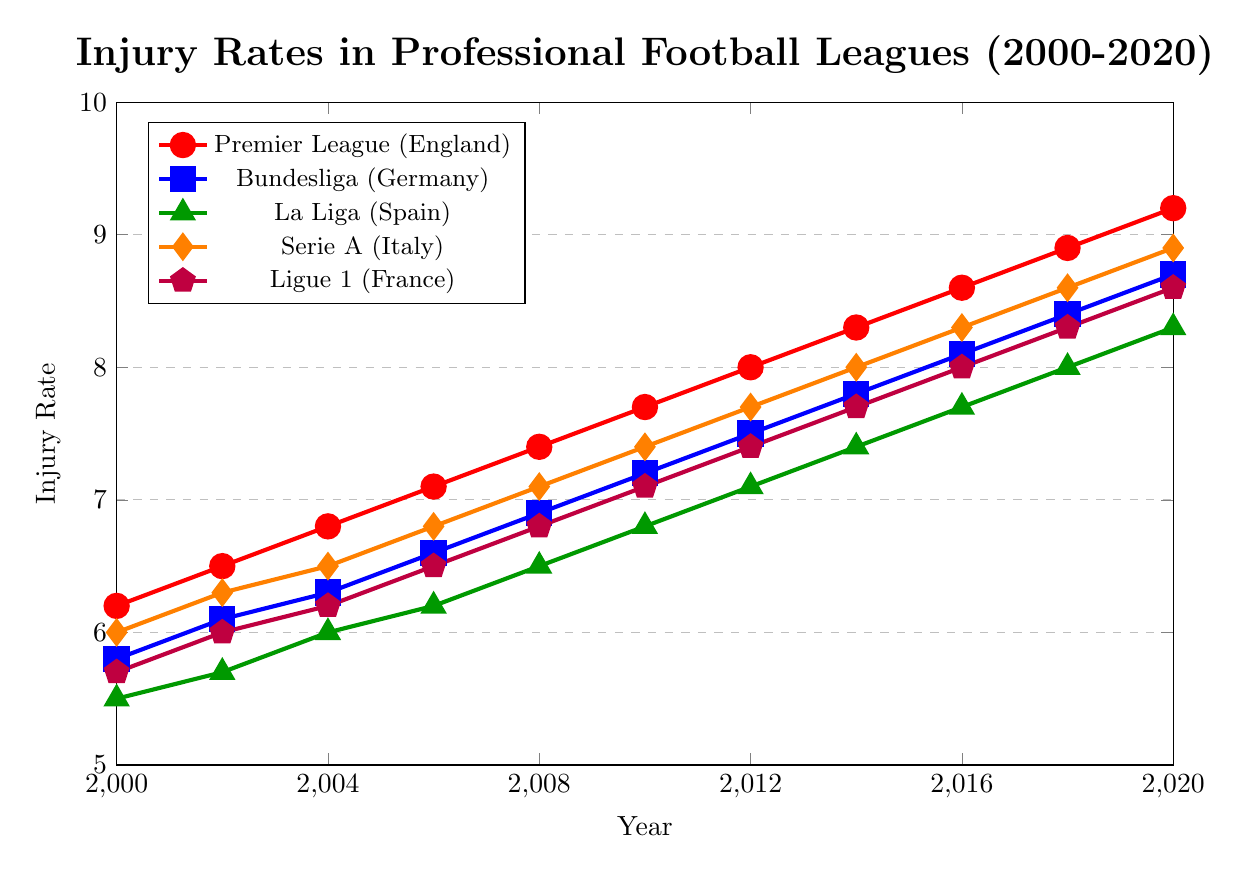What's the trend of injury rates in the Premier League (England) from 2000 to 2020? The red line representing the Premier League (England) shows a consistent upward trend from 2000 (6.2) to 2020 (9.2). Each point along the red line marks an increase over time, indicating a steady rise in injury rates for this league over the 20-year period.
Answer: Upward trend Which league had the lowest injury rate in 2000 and what was the rate? In 2000, the green line representing La Liga (Spain) is the lowest among all the lines, with an injury rate of 5.5.
Answer: La Liga (Spain), 5.5 By how much did the injury rate increase in Serie A (Italy) from 2000 to 2020? The orange line representing Serie A (Italy) starts at 6.0 in 2000 and ends at 8.9 in 2020. The increase can be calculated as 8.9 - 6.0 = 2.9.
Answer: 2.9 Which league's injury rate exceeded 8.0 first and in which year did it occur? The red line for the Premier League (England) first crosses the 8.0 mark in 2012. It reaches an injury rate of 8.0 in that year, making it the first league to exceed this rate.
Answer: Premier League (England), 2012 Compare the injury rates of Bundesliga (Germany) and Ligue 1 (France) in 2010. Which had the higher rate? In 2010, the blue line for Bundesliga (Germany) is at 7.2, while the purple line for Ligue 1 (France) is at 7.1. Therefore, Bundesliga (Germany) had a slightly higher injury rate.
Answer: Bundesliga (Germany) What is the average injury rate in La Liga (Spain) from 2000 to 2020? Summing up the injury rates for La Liga (Spain) from 2000 to 2020 gives: 5.5 + 5.7 + 6.0 + 6.2 + 6.5 + 6.8 + 7.1 + 7.4 + 7.7 + 8.0 + 8.3 = 75.2. There are 11 data points, so the average is 75.2 / 11 ≈ 6.84.
Answer: 6.84 Which league showed the smallest change in injury rates over the 20-year period? To find the smallest change, compare the initial and final values for each league: Premier League (England) from 6.2 to 9.2 (change of 3.0), Bundesliga (Germany) from 5.8 to 8.7 (change of 2.9), La Liga (Spain) from 5.5 to 8.3 (change of 2.8), Serie A (Italy) from 6.0 to 8.9 (change of 2.9), Ligue 1 (France) from 5.7 to 8.6 (change of 2.9). La Liga (Spain) shows the smallest change of 2.8.
Answer: La Liga (Spain) Between 2006 and 2016, which league had the highest rate of increase in injury rates? Calculate the increase for each league from 2006 to 2016:
- Premier League (England): 8.6 - 7.1 = 1.5
- Bundesliga (Germany): 8.1 - 6.6 = 1.5
- La Liga (Spain): 7.7 - 6.2 = 1.5
- Serie A (Italy): 8.3 - 6.8 = 1.5
- Ligue 1 (France): 8.0 - 6.5 = 1.5
All leagues had identical increases of 1.5 from 2006 to 2016.
Answer: All leagues, 1.5 